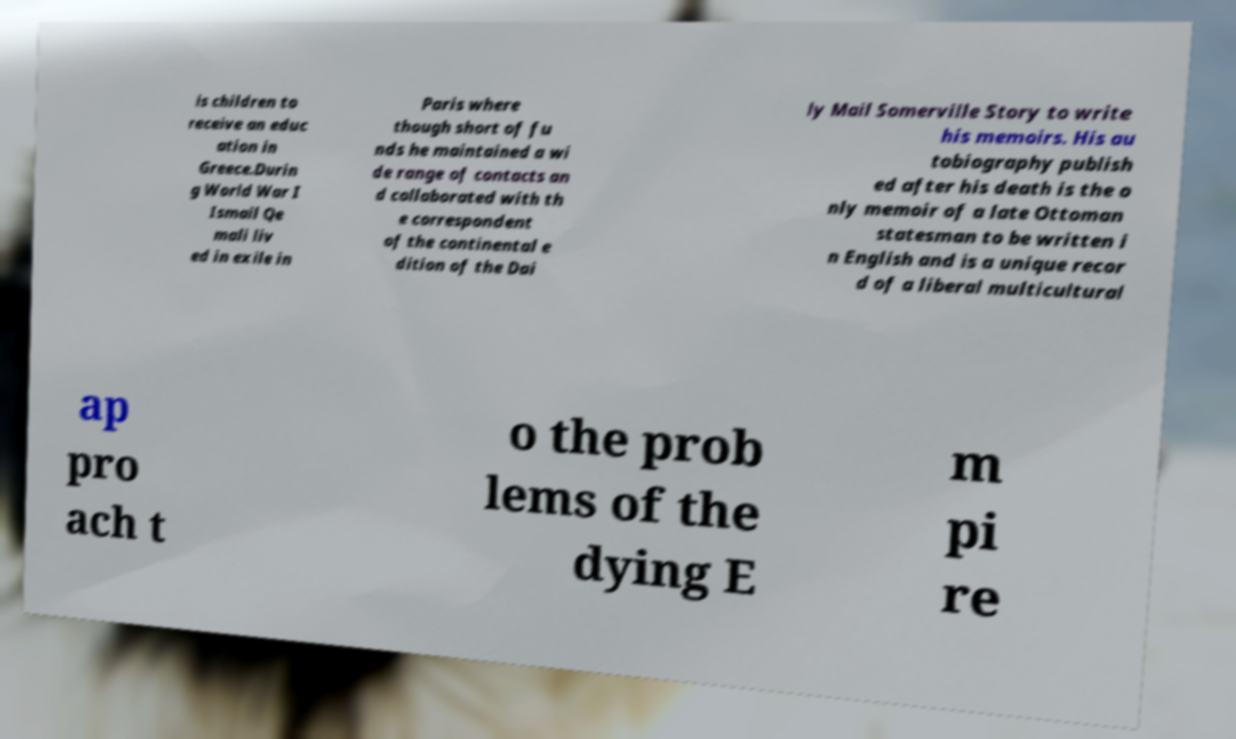Please identify and transcribe the text found in this image. is children to receive an educ ation in Greece.Durin g World War I Ismail Qe mali liv ed in exile in Paris where though short of fu nds he maintained a wi de range of contacts an d collaborated with th e correspondent of the continental e dition of the Dai ly Mail Somerville Story to write his memoirs. His au tobiography publish ed after his death is the o nly memoir of a late Ottoman statesman to be written i n English and is a unique recor d of a liberal multicultural ap pro ach t o the prob lems of the dying E m pi re 